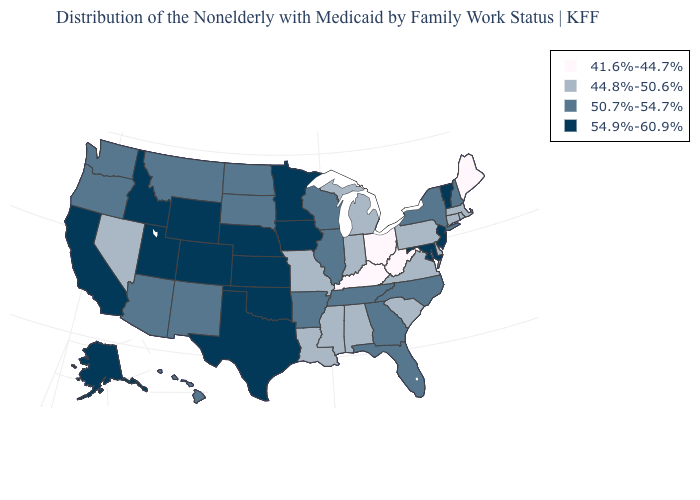What is the value of New Mexico?
Keep it brief. 50.7%-54.7%. Among the states that border Utah , does Colorado have the highest value?
Short answer required. Yes. What is the value of Colorado?
Give a very brief answer. 54.9%-60.9%. Name the states that have a value in the range 44.8%-50.6%?
Short answer required. Alabama, Connecticut, Delaware, Indiana, Louisiana, Massachusetts, Michigan, Mississippi, Missouri, Nevada, Pennsylvania, Rhode Island, South Carolina, Virginia. What is the highest value in the West ?
Write a very short answer. 54.9%-60.9%. Name the states that have a value in the range 44.8%-50.6%?
Write a very short answer. Alabama, Connecticut, Delaware, Indiana, Louisiana, Massachusetts, Michigan, Mississippi, Missouri, Nevada, Pennsylvania, Rhode Island, South Carolina, Virginia. What is the value of Wisconsin?
Be succinct. 50.7%-54.7%. Name the states that have a value in the range 44.8%-50.6%?
Write a very short answer. Alabama, Connecticut, Delaware, Indiana, Louisiana, Massachusetts, Michigan, Mississippi, Missouri, Nevada, Pennsylvania, Rhode Island, South Carolina, Virginia. Name the states that have a value in the range 54.9%-60.9%?
Keep it brief. Alaska, California, Colorado, Idaho, Iowa, Kansas, Maryland, Minnesota, Nebraska, New Jersey, Oklahoma, Texas, Utah, Vermont, Wyoming. Among the states that border South Dakota , which have the highest value?
Keep it brief. Iowa, Minnesota, Nebraska, Wyoming. What is the highest value in the MidWest ?
Quick response, please. 54.9%-60.9%. Does Missouri have the same value as Louisiana?
Be succinct. Yes. Which states have the highest value in the USA?
Quick response, please. Alaska, California, Colorado, Idaho, Iowa, Kansas, Maryland, Minnesota, Nebraska, New Jersey, Oklahoma, Texas, Utah, Vermont, Wyoming. What is the value of Alaska?
Short answer required. 54.9%-60.9%. What is the highest value in the USA?
Quick response, please. 54.9%-60.9%. 